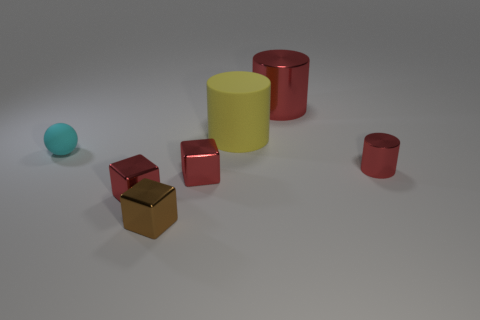Does the big object left of the large red metal cylinder have the same color as the metallic cylinder that is behind the matte sphere?
Make the answer very short. No. What shape is the tiny red thing on the left side of the brown metal object?
Keep it short and to the point. Cube. The tiny sphere has what color?
Your answer should be compact. Cyan. There is a brown object that is the same material as the tiny red cylinder; what shape is it?
Provide a short and direct response. Cube. There is a cylinder in front of the yellow rubber object; is it the same size as the small cyan sphere?
Give a very brief answer. Yes. How many objects are things in front of the tiny metallic cylinder or matte things that are in front of the yellow matte object?
Your response must be concise. 4. Does the metal cylinder in front of the small cyan matte ball have the same color as the small ball?
Make the answer very short. No. What number of metallic things are either small cyan things or large yellow objects?
Provide a short and direct response. 0. What is the shape of the small brown shiny thing?
Ensure brevity in your answer.  Cube. Is there any other thing that has the same material as the big yellow cylinder?
Your response must be concise. Yes. 